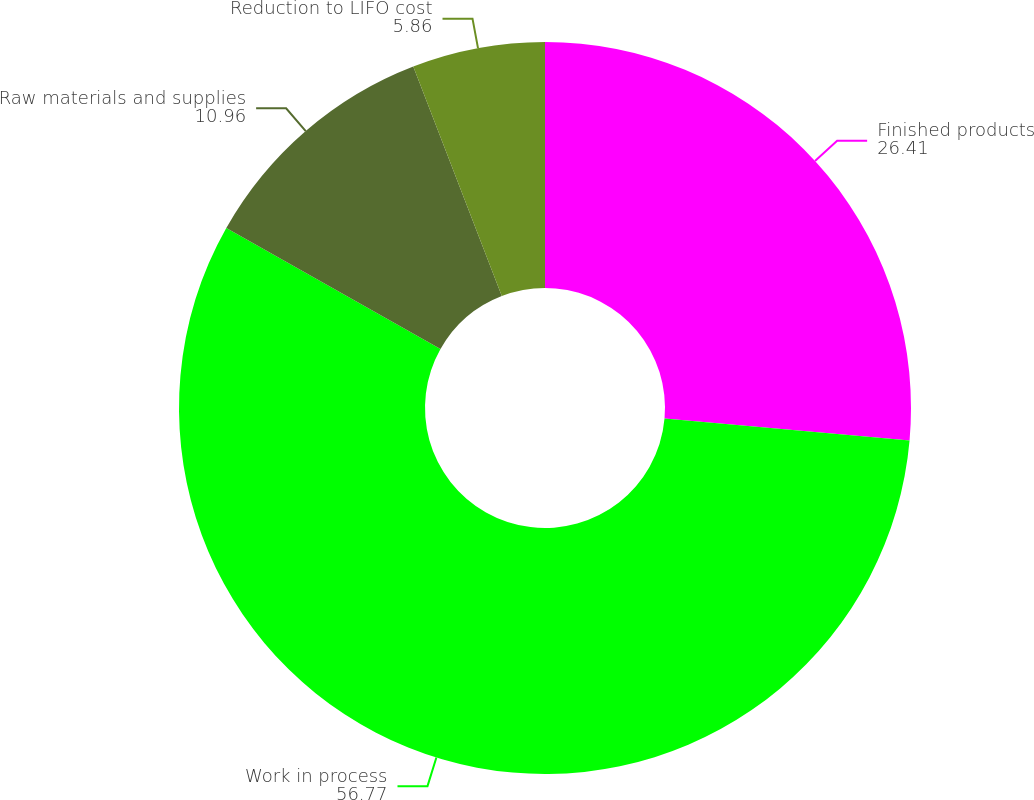<chart> <loc_0><loc_0><loc_500><loc_500><pie_chart><fcel>Finished products<fcel>Work in process<fcel>Raw materials and supplies<fcel>Reduction to LIFO cost<nl><fcel>26.41%<fcel>56.77%<fcel>10.96%<fcel>5.86%<nl></chart> 